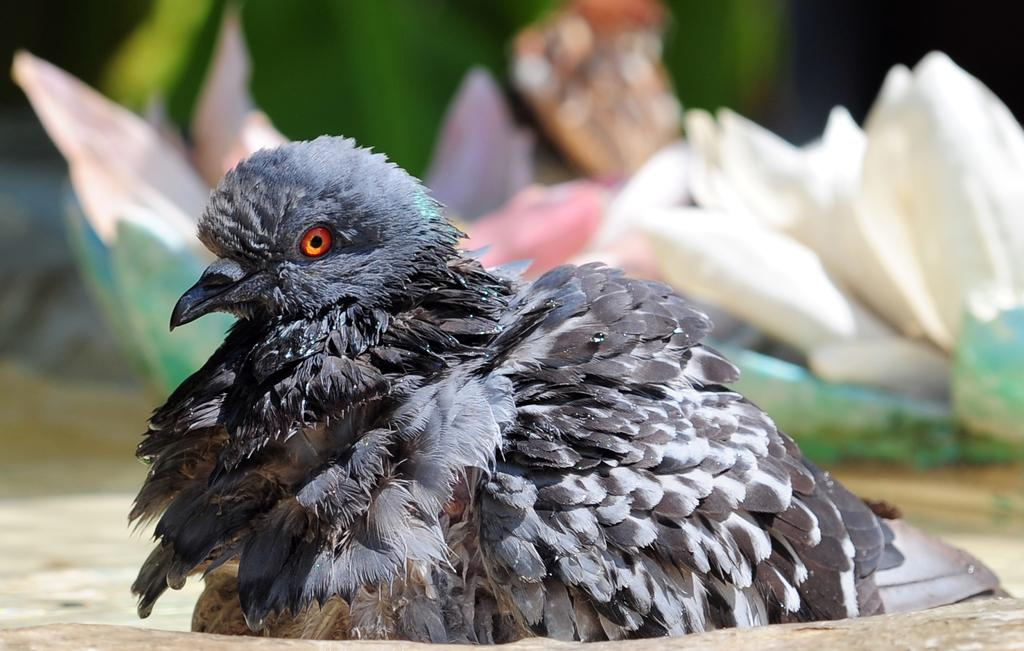What type of animal is present in the image? There is a bird in the image. What color is the bird? The bird is black in color. What can be seen in the background of the image? There are flowers visible in the background of the image. What is located at the bottom of the image? There is a stone at the bottom of the image. What type of part is being used by the bird in the image? There is no part being used by the bird in the image; it is simply a bird perched on a surface. 